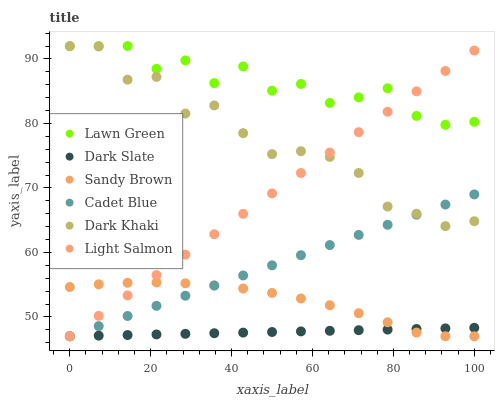Does Dark Slate have the minimum area under the curve?
Answer yes or no. Yes. Does Lawn Green have the maximum area under the curve?
Answer yes or no. Yes. Does Light Salmon have the minimum area under the curve?
Answer yes or no. No. Does Light Salmon have the maximum area under the curve?
Answer yes or no. No. Is Dark Slate the smoothest?
Answer yes or no. Yes. Is Lawn Green the roughest?
Answer yes or no. Yes. Is Light Salmon the smoothest?
Answer yes or no. No. Is Light Salmon the roughest?
Answer yes or no. No. Does Light Salmon have the lowest value?
Answer yes or no. Yes. Does Dark Khaki have the lowest value?
Answer yes or no. No. Does Dark Khaki have the highest value?
Answer yes or no. Yes. Does Light Salmon have the highest value?
Answer yes or no. No. Is Dark Slate less than Dark Khaki?
Answer yes or no. Yes. Is Lawn Green greater than Sandy Brown?
Answer yes or no. Yes. Does Sandy Brown intersect Dark Slate?
Answer yes or no. Yes. Is Sandy Brown less than Dark Slate?
Answer yes or no. No. Is Sandy Brown greater than Dark Slate?
Answer yes or no. No. Does Dark Slate intersect Dark Khaki?
Answer yes or no. No. 